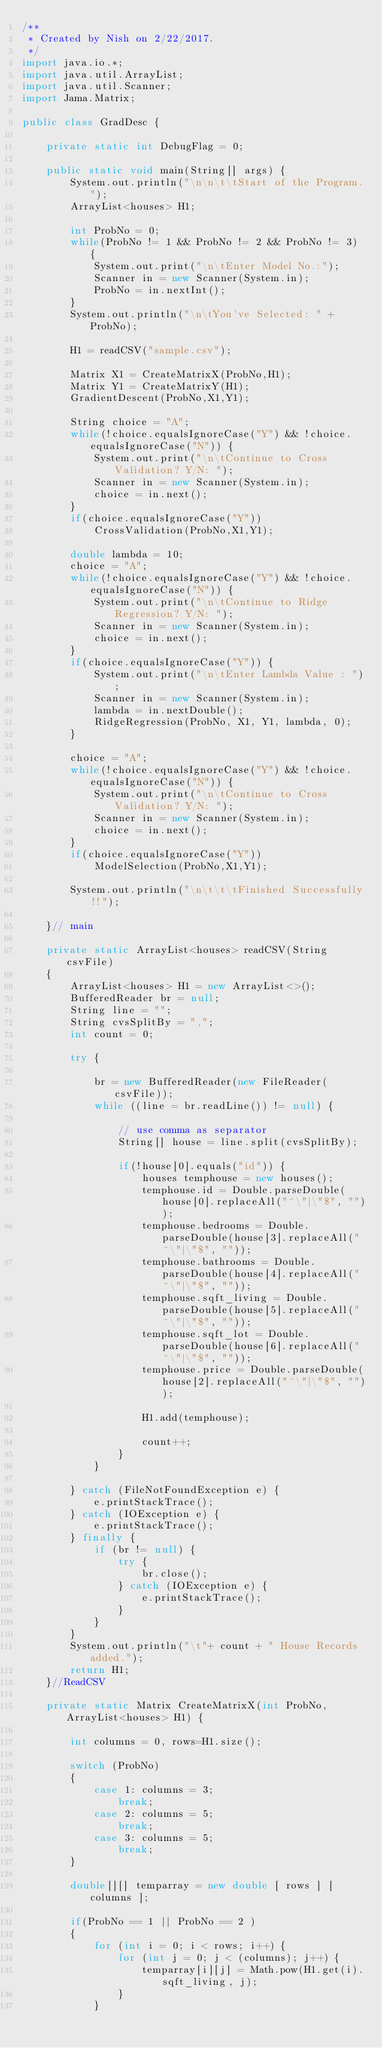Convert code to text. <code><loc_0><loc_0><loc_500><loc_500><_Java_>/**
 * Created by Nish on 2/22/2017.
 */
import java.io.*;
import java.util.ArrayList;
import java.util.Scanner;
import Jama.Matrix;

public class GradDesc {

    private static int DebugFlag = 0;

    public static void main(String[] args) {
        System.out.println("\n\n\t\tStart of the Program.");
        ArrayList<houses> H1;

        int ProbNo = 0;
        while(ProbNo != 1 && ProbNo != 2 && ProbNo != 3) {
            System.out.print("\n\tEnter Model No.:");
            Scanner in = new Scanner(System.in);
            ProbNo = in.nextInt();
        }
        System.out.println("\n\tYou've Selected: " + ProbNo);

        H1 = readCSV("sample.csv");

        Matrix X1 = CreateMatrixX(ProbNo,H1);
        Matrix Y1 = CreateMatrixY(H1);
        GradientDescent(ProbNo,X1,Y1);

        String choice = "A";
        while(!choice.equalsIgnoreCase("Y") && !choice.equalsIgnoreCase("N")) {
            System.out.print("\n\tContinue to Cross Validation? Y/N: ");
            Scanner in = new Scanner(System.in);
            choice = in.next();
        }
        if(choice.equalsIgnoreCase("Y"))
            CrossValidation(ProbNo,X1,Y1);

        double lambda = 10;
        choice = "A";
        while(!choice.equalsIgnoreCase("Y") && !choice.equalsIgnoreCase("N")) {
            System.out.print("\n\tContinue to Ridge Regression? Y/N: ");
            Scanner in = new Scanner(System.in);
            choice = in.next();
        }
        if(choice.equalsIgnoreCase("Y")) {
            System.out.print("\n\tEnter Lambda Value : ");
            Scanner in = new Scanner(System.in);
            lambda = in.nextDouble();
            RidgeRegression(ProbNo, X1, Y1, lambda, 0);
        }

        choice = "A";
        while(!choice.equalsIgnoreCase("Y") && !choice.equalsIgnoreCase("N")) {
            System.out.print("\n\tContinue to Cross Validation? Y/N: ");
            Scanner in = new Scanner(System.in);
            choice = in.next();
        }
        if(choice.equalsIgnoreCase("Y"))
            ModelSelection(ProbNo,X1,Y1);

        System.out.println("\n\t\t\tFinished Successfully!!");

    }// main

    private static ArrayList<houses> readCSV(String csvFile)
    {
        ArrayList<houses> H1 = new ArrayList<>();
        BufferedReader br = null;
        String line = "";
        String cvsSplitBy = ",";
        int count = 0;

        try {

            br = new BufferedReader(new FileReader(csvFile));
            while ((line = br.readLine()) != null) {

                // use comma as separator
                String[] house = line.split(cvsSplitBy);

                if(!house[0].equals("id")) {
                    houses temphouse = new houses();
                    temphouse.id = Double.parseDouble(house[0].replaceAll("^\"|\"$", ""));
                    temphouse.bedrooms = Double.parseDouble(house[3].replaceAll("^\"|\"$", ""));
                    temphouse.bathrooms = Double.parseDouble(house[4].replaceAll("^\"|\"$", ""));
                    temphouse.sqft_living = Double.parseDouble(house[5].replaceAll("^\"|\"$", ""));
                    temphouse.sqft_lot = Double.parseDouble(house[6].replaceAll("^\"|\"$", ""));
                    temphouse.price = Double.parseDouble(house[2].replaceAll("^\"|\"$", ""));

                    H1.add(temphouse);

                    count++;
                }
            }

        } catch (FileNotFoundException e) {
            e.printStackTrace();
        } catch (IOException e) {
            e.printStackTrace();
        } finally {
            if (br != null) {
                try {
                    br.close();
                } catch (IOException e) {
                    e.printStackTrace();
                }
            }
        }
        System.out.println("\t"+ count + " House Records added.");
        return H1;
    }//ReadCSV

    private static Matrix CreateMatrixX(int ProbNo, ArrayList<houses> H1) {

        int columns = 0, rows=H1.size();

        switch (ProbNo)
        {
            case 1: columns = 3;
                break;
            case 2: columns = 5;
                break;
            case 3: columns = 5;
                break;
        }

        double[][] temparray = new double [ rows ] [ columns ];

        if(ProbNo == 1 || ProbNo == 2 )
        {
            for (int i = 0; i < rows; i++) {
                for (int j = 0; j < (columns); j++) {
                    temparray[i][j] = Math.pow(H1.get(i).sqft_living, j);
                }
            }</code> 